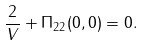<formula> <loc_0><loc_0><loc_500><loc_500>\frac { 2 } { V } + \Pi _ { 2 2 } ( 0 , 0 ) = 0 .</formula> 